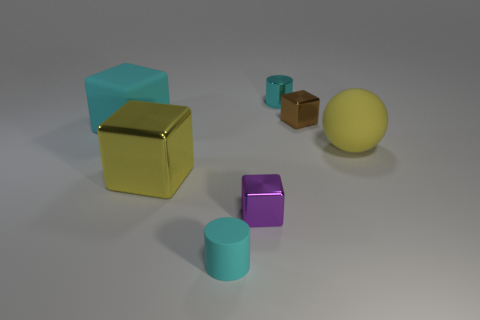Subtract all purple shiny cubes. How many cubes are left? 3 Subtract all purple blocks. How many blocks are left? 3 Add 1 large yellow metal objects. How many objects exist? 8 Subtract all spheres. How many objects are left? 6 Subtract all green cubes. Subtract all red cylinders. How many cubes are left? 4 Add 7 green rubber cylinders. How many green rubber cylinders exist? 7 Subtract 0 gray blocks. How many objects are left? 7 Subtract all small brown cubes. Subtract all large blocks. How many objects are left? 4 Add 6 tiny metallic objects. How many tiny metallic objects are left? 9 